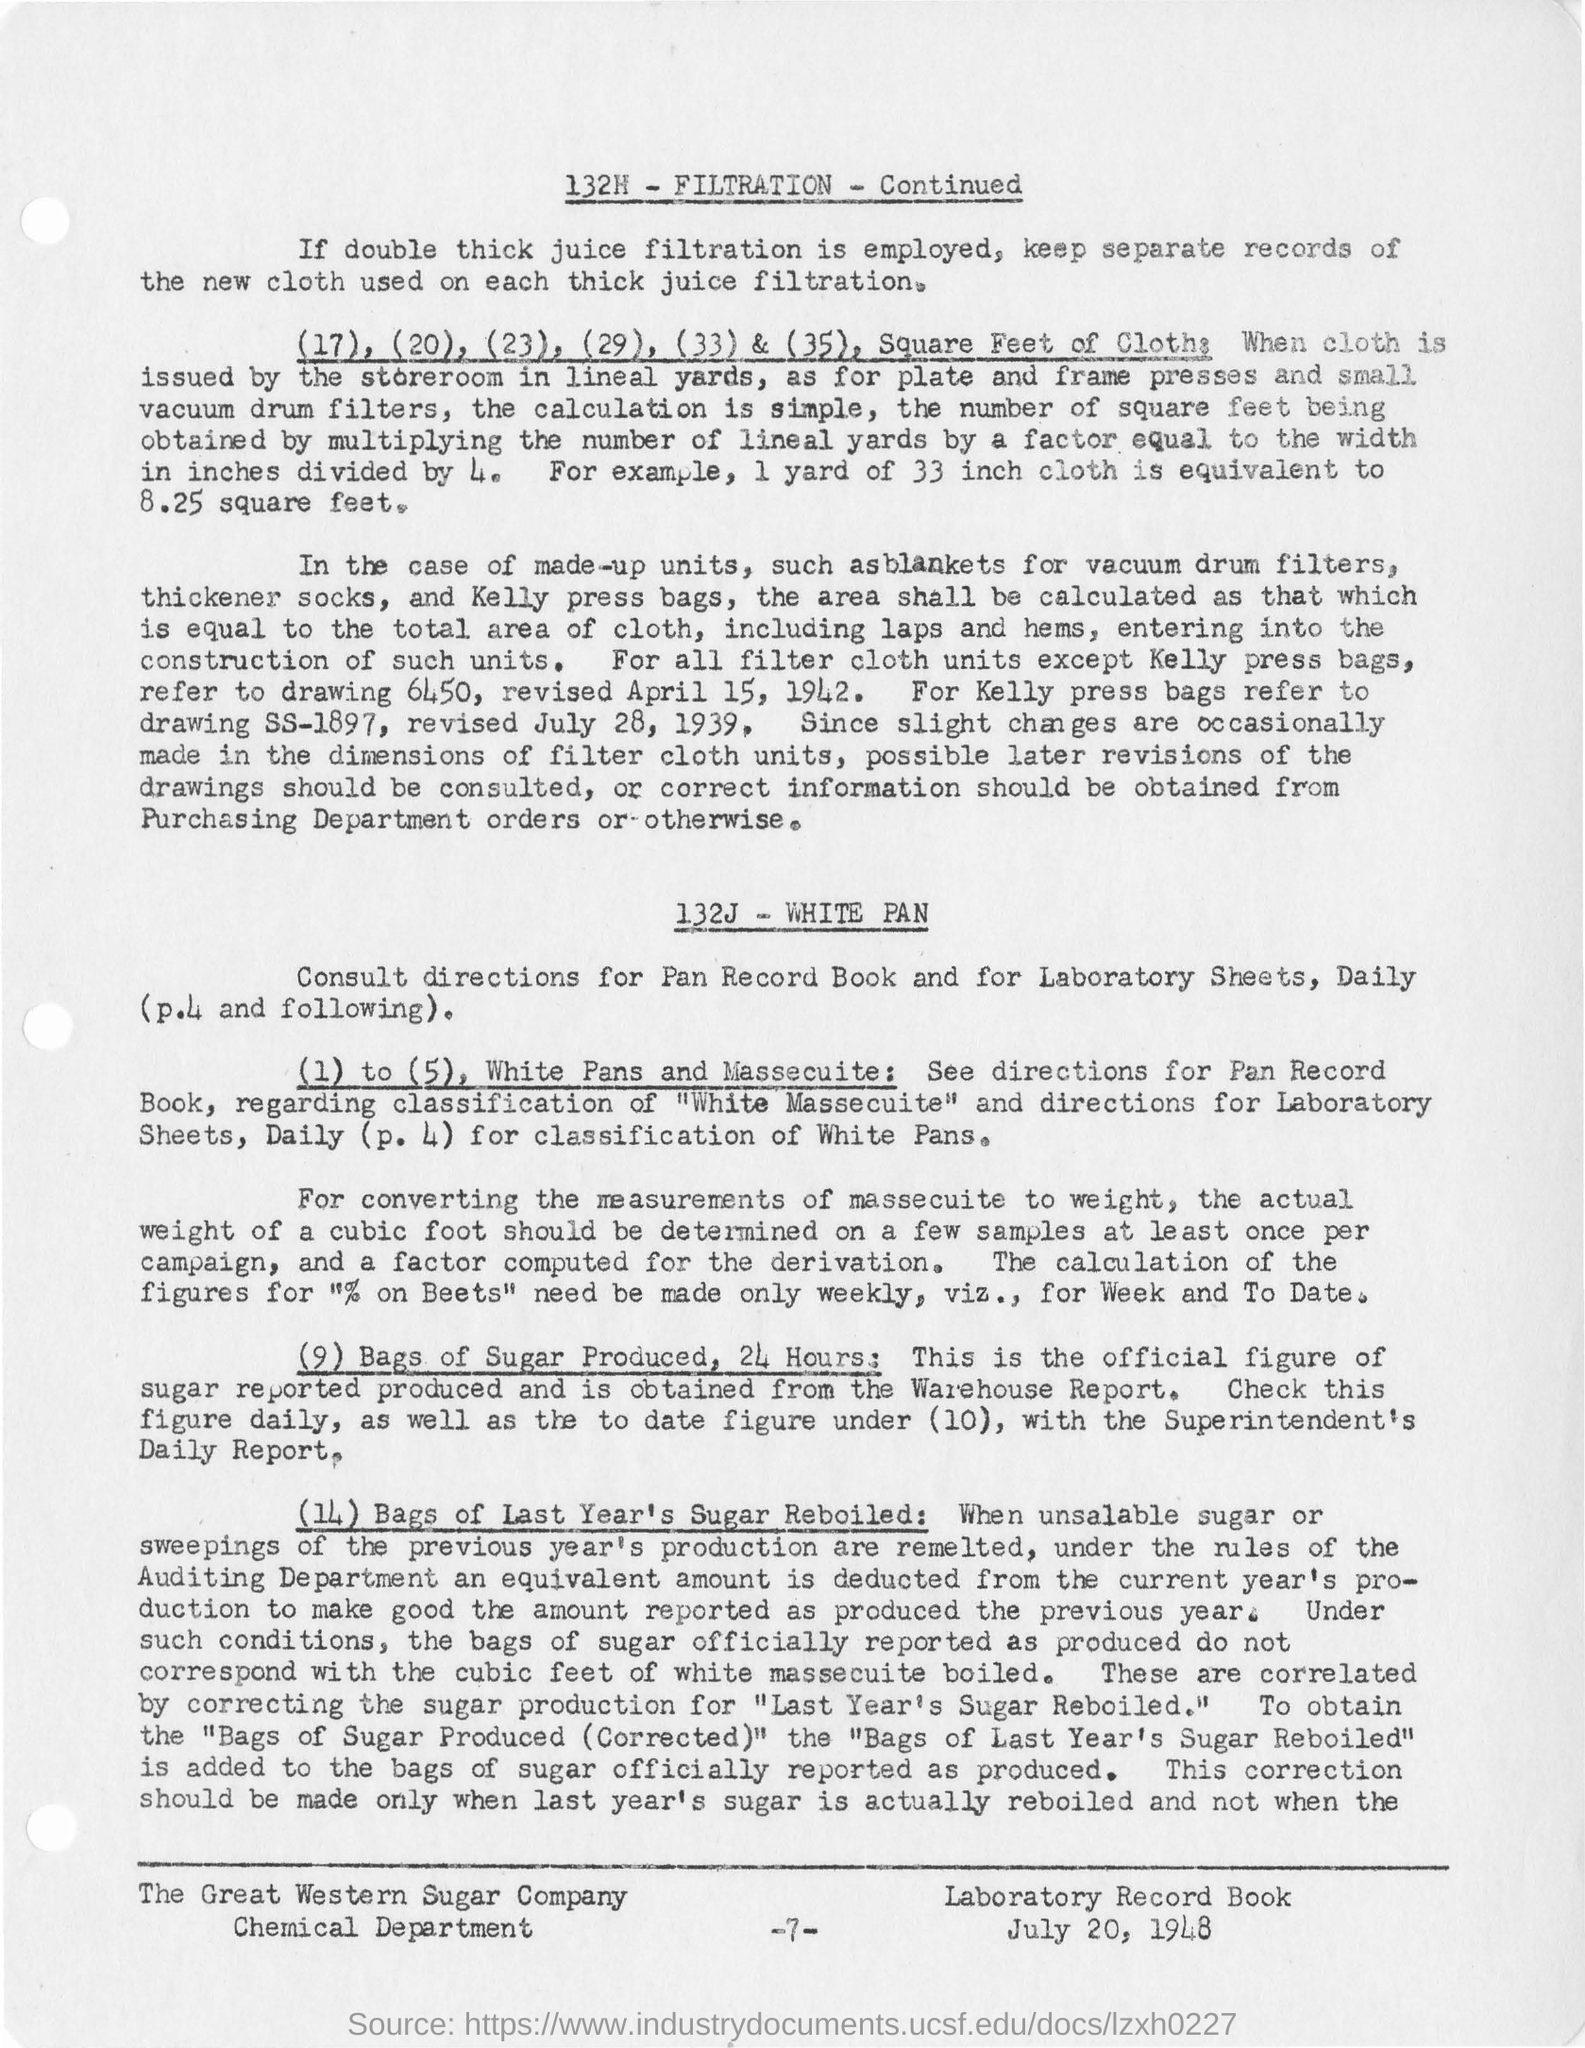Point out several critical features in this image. The page number mentioned in this document is -7-.. The sample cubic foot must be analyzed at least once per campaign. According to the warehouse report, the official figure for the amount of sugar produced in 24 hours is available. I declare that the press bag identified in drawing 6450 is not referred to as Kelly press bags. 1 yard of 33 inch cloth is equivalent to 8.25 square feet. 